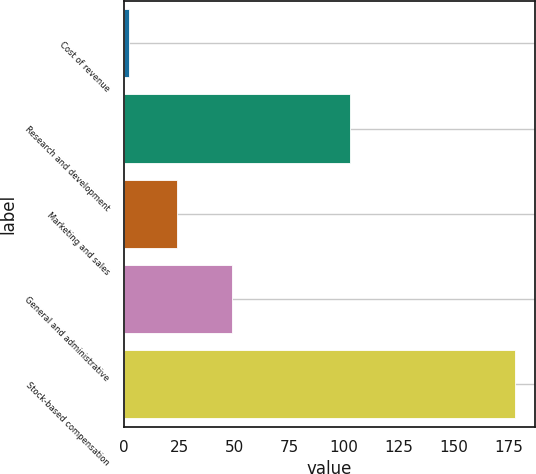Convert chart. <chart><loc_0><loc_0><loc_500><loc_500><bar_chart><fcel>Cost of revenue<fcel>Research and development<fcel>Marketing and sales<fcel>General and administrative<fcel>Stock-based compensation<nl><fcel>2<fcel>103<fcel>24<fcel>49<fcel>178<nl></chart> 